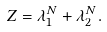Convert formula to latex. <formula><loc_0><loc_0><loc_500><loc_500>Z = \lambda _ { 1 } ^ { N } + \lambda _ { 2 } ^ { N } .</formula> 